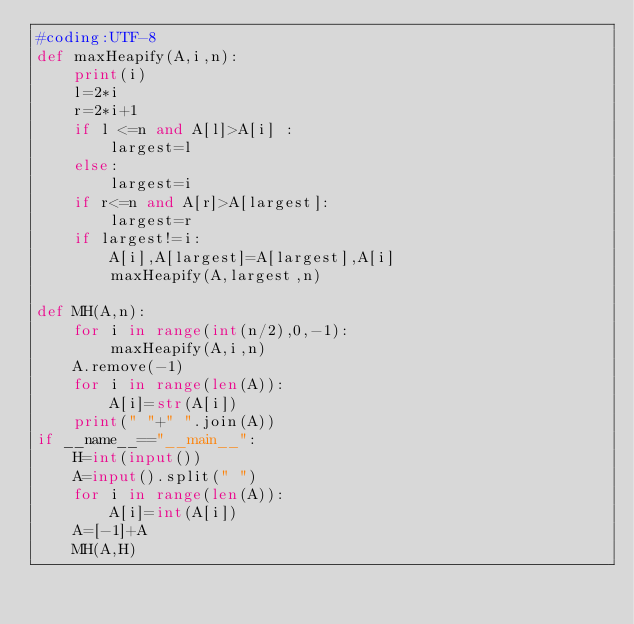Convert code to text. <code><loc_0><loc_0><loc_500><loc_500><_Python_>#coding:UTF-8
def maxHeapify(A,i,n):
    print(i)
    l=2*i
    r=2*i+1
    if l <=n and A[l]>A[i] :
        largest=l
    else:
        largest=i
    if r<=n and A[r]>A[largest]:
        largest=r
    if largest!=i:
        A[i],A[largest]=A[largest],A[i]
        maxHeapify(A,largest,n)

def MH(A,n):
    for i in range(int(n/2),0,-1):
        maxHeapify(A,i,n)
    A.remove(-1)
    for i in range(len(A)):
        A[i]=str(A[i])
    print(" "+" ".join(A))        
if __name__=="__main__":
    H=int(input())
    A=input().split(" ")
    for i in range(len(A)):
        A[i]=int(A[i])
    A=[-1]+A
    MH(A,H)</code> 